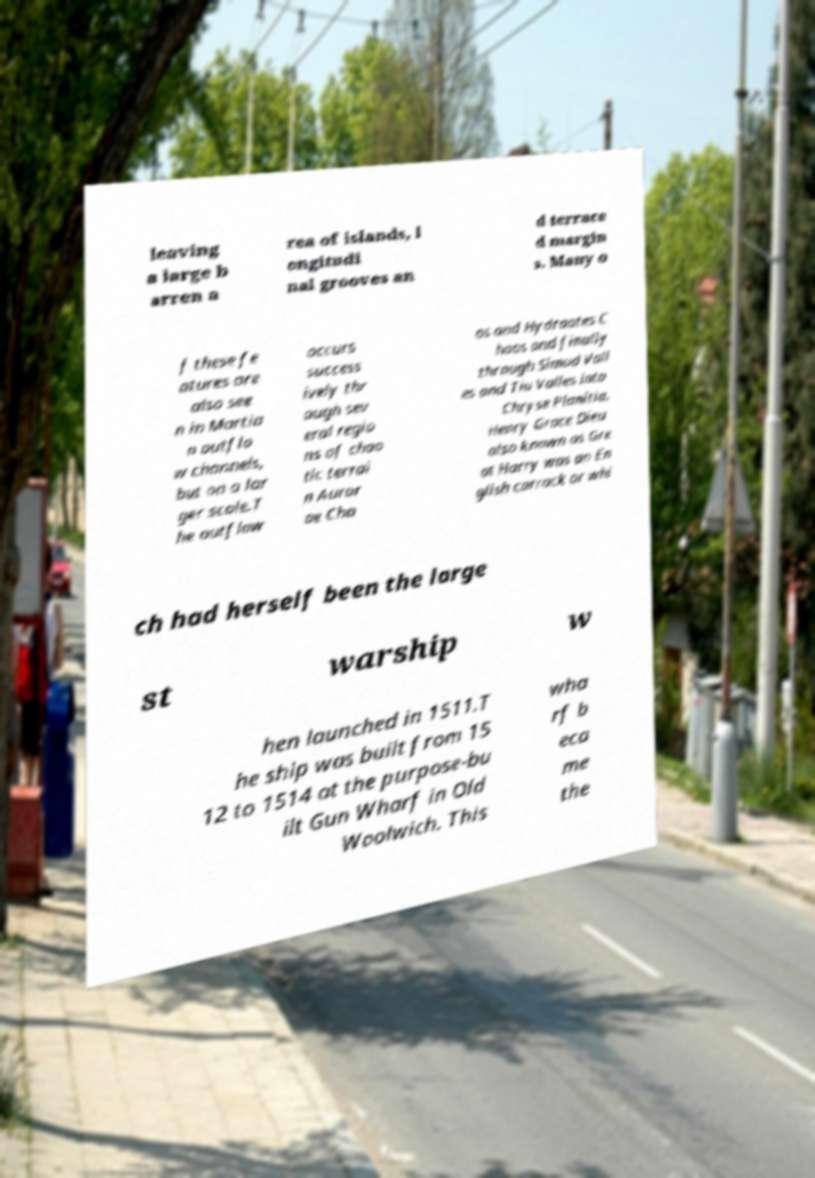Could you extract and type out the text from this image? leaving a large b arren a rea of islands, l ongitudi nal grooves an d terrace d margin s. Many o f these fe atures are also see n in Martia n outflo w channels, but on a lar ger scale.T he outflow occurs success ively thr ough sev eral regio ns of chao tic terrai n Auror ae Cha os and Hydraotes C haos and finally through Simud Vall es and Tiu Valles into Chryse Planitia. Henry Grace Dieu also known as Gre at Harry was an En glish carrack or whi ch had herself been the large st warship w hen launched in 1511.T he ship was built from 15 12 to 1514 at the purpose-bu ilt Gun Wharf in Old Woolwich. This wha rf b eca me the 